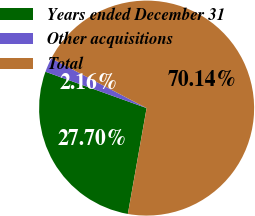Convert chart. <chart><loc_0><loc_0><loc_500><loc_500><pie_chart><fcel>Years ended December 31<fcel>Other acquisitions<fcel>Total<nl><fcel>27.7%<fcel>2.16%<fcel>70.14%<nl></chart> 